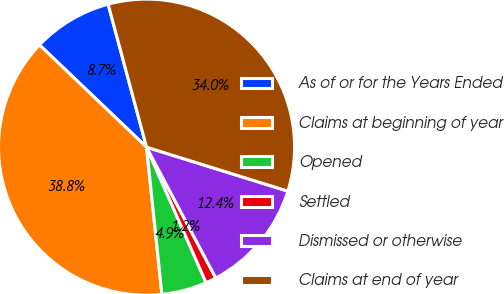<chart> <loc_0><loc_0><loc_500><loc_500><pie_chart><fcel>As of or for the Years Ended<fcel>Claims at beginning of year<fcel>Opened<fcel>Settled<fcel>Dismissed or otherwise<fcel>Claims at end of year<nl><fcel>8.69%<fcel>38.79%<fcel>4.93%<fcel>1.16%<fcel>12.45%<fcel>33.98%<nl></chart> 